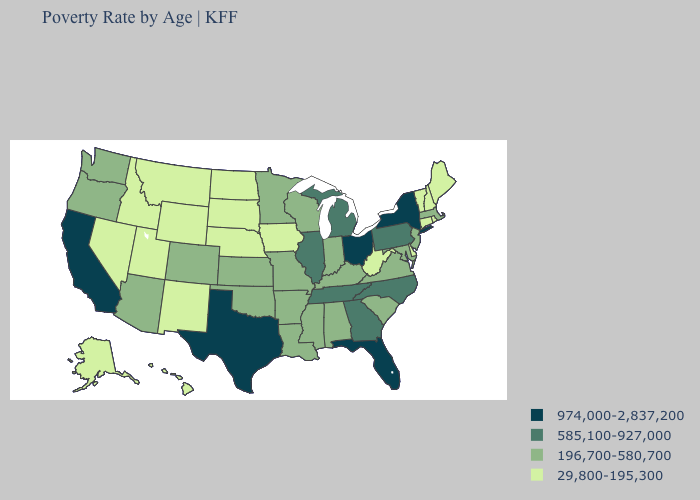Does Kentucky have the highest value in the South?
Write a very short answer. No. Among the states that border New Mexico , does Utah have the lowest value?
Write a very short answer. Yes. Name the states that have a value in the range 585,100-927,000?
Keep it brief. Georgia, Illinois, Michigan, North Carolina, Pennsylvania, Tennessee. How many symbols are there in the legend?
Concise answer only. 4. Which states hav the highest value in the Northeast?
Write a very short answer. New York. Name the states that have a value in the range 29,800-195,300?
Give a very brief answer. Alaska, Connecticut, Delaware, Hawaii, Idaho, Iowa, Maine, Montana, Nebraska, Nevada, New Hampshire, New Mexico, North Dakota, Rhode Island, South Dakota, Utah, Vermont, West Virginia, Wyoming. What is the value of Mississippi?
Short answer required. 196,700-580,700. What is the value of Kansas?
Concise answer only. 196,700-580,700. Does Georgia have a lower value than North Carolina?
Keep it brief. No. Which states have the lowest value in the West?
Keep it brief. Alaska, Hawaii, Idaho, Montana, Nevada, New Mexico, Utah, Wyoming. What is the lowest value in states that border Nebraska?
Quick response, please. 29,800-195,300. Which states have the lowest value in the USA?
Answer briefly. Alaska, Connecticut, Delaware, Hawaii, Idaho, Iowa, Maine, Montana, Nebraska, Nevada, New Hampshire, New Mexico, North Dakota, Rhode Island, South Dakota, Utah, Vermont, West Virginia, Wyoming. Name the states that have a value in the range 974,000-2,837,200?
Concise answer only. California, Florida, New York, Ohio, Texas. What is the value of Nebraska?
Write a very short answer. 29,800-195,300. What is the highest value in the West ?
Short answer required. 974,000-2,837,200. 